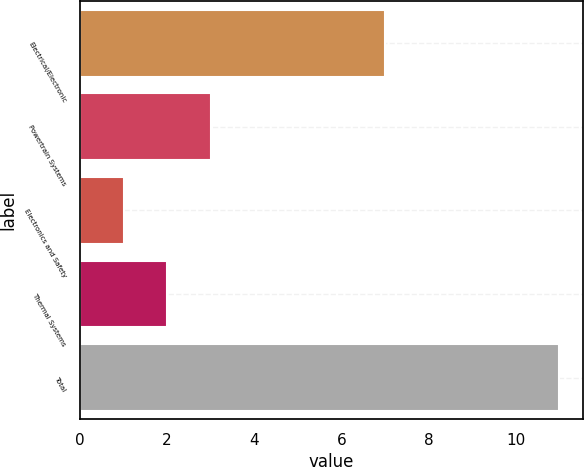Convert chart. <chart><loc_0><loc_0><loc_500><loc_500><bar_chart><fcel>Electrical/Electronic<fcel>Powertrain Systems<fcel>Electronics and Safety<fcel>Thermal Systems<fcel>Total<nl><fcel>7<fcel>3<fcel>1<fcel>2<fcel>11<nl></chart> 